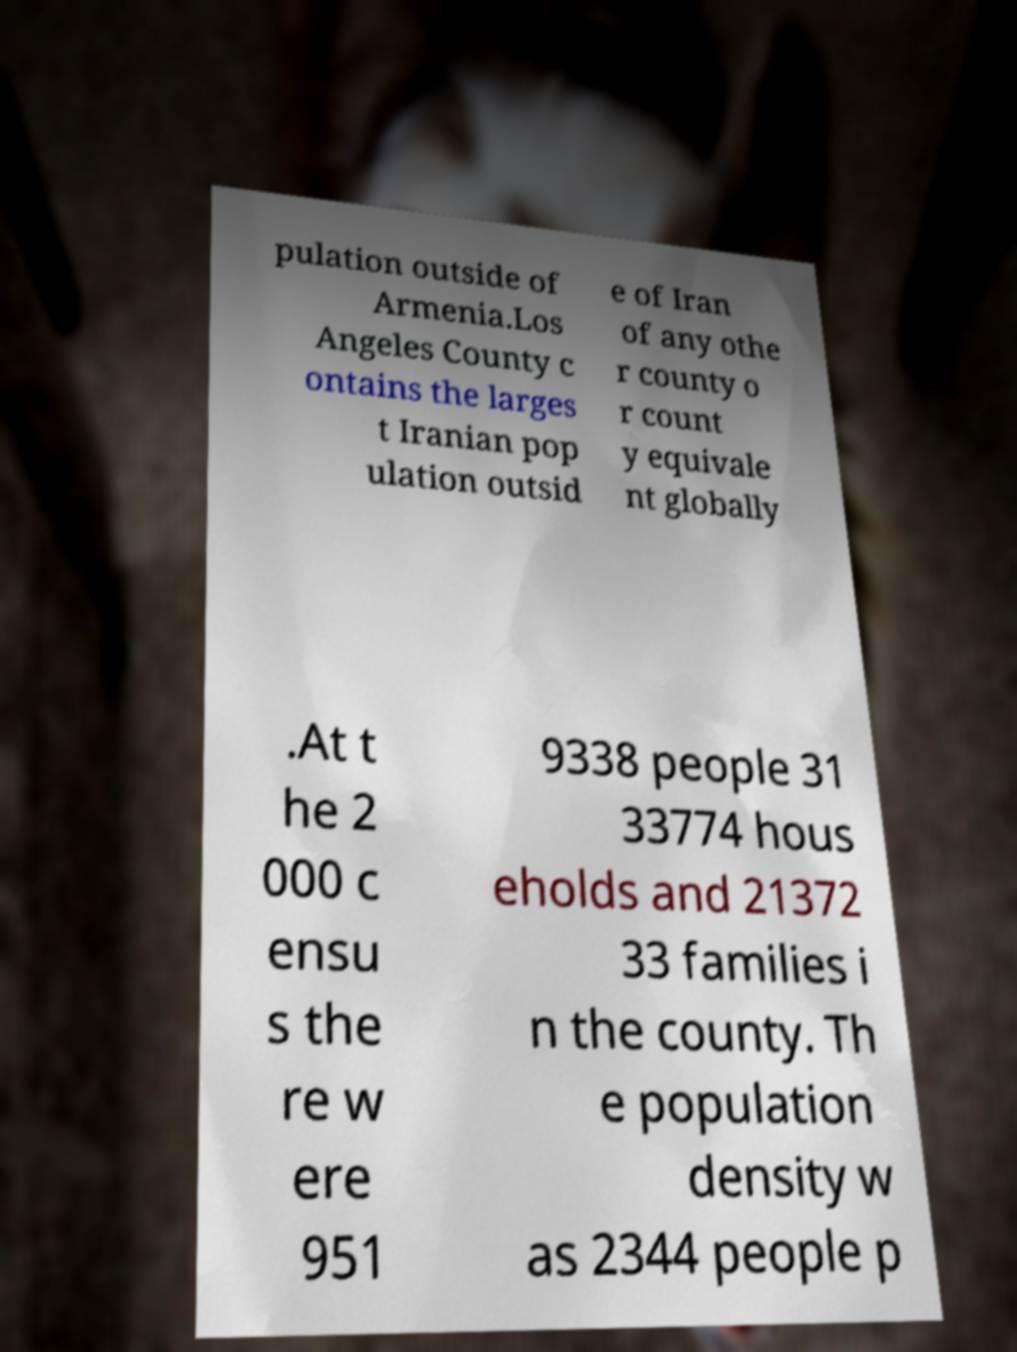Please identify and transcribe the text found in this image. pulation outside of Armenia.Los Angeles County c ontains the larges t Iranian pop ulation outsid e of Iran of any othe r county o r count y equivale nt globally .At t he 2 000 c ensu s the re w ere 951 9338 people 31 33774 hous eholds and 21372 33 families i n the county. Th e population density w as 2344 people p 